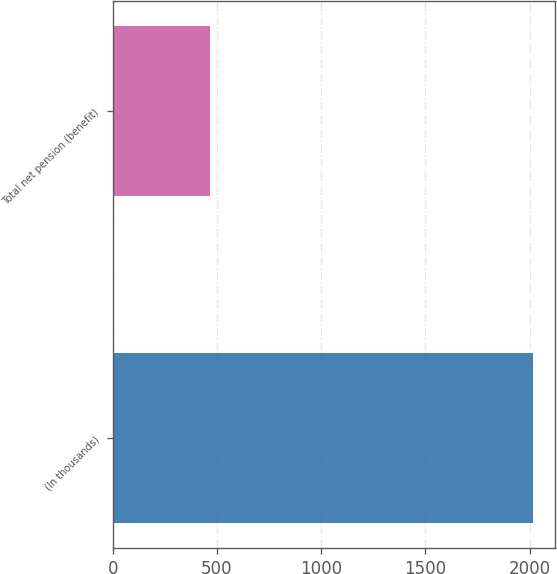Convert chart. <chart><loc_0><loc_0><loc_500><loc_500><bar_chart><fcel>(In thousands)<fcel>Total net pension (benefit)<nl><fcel>2018<fcel>468<nl></chart> 